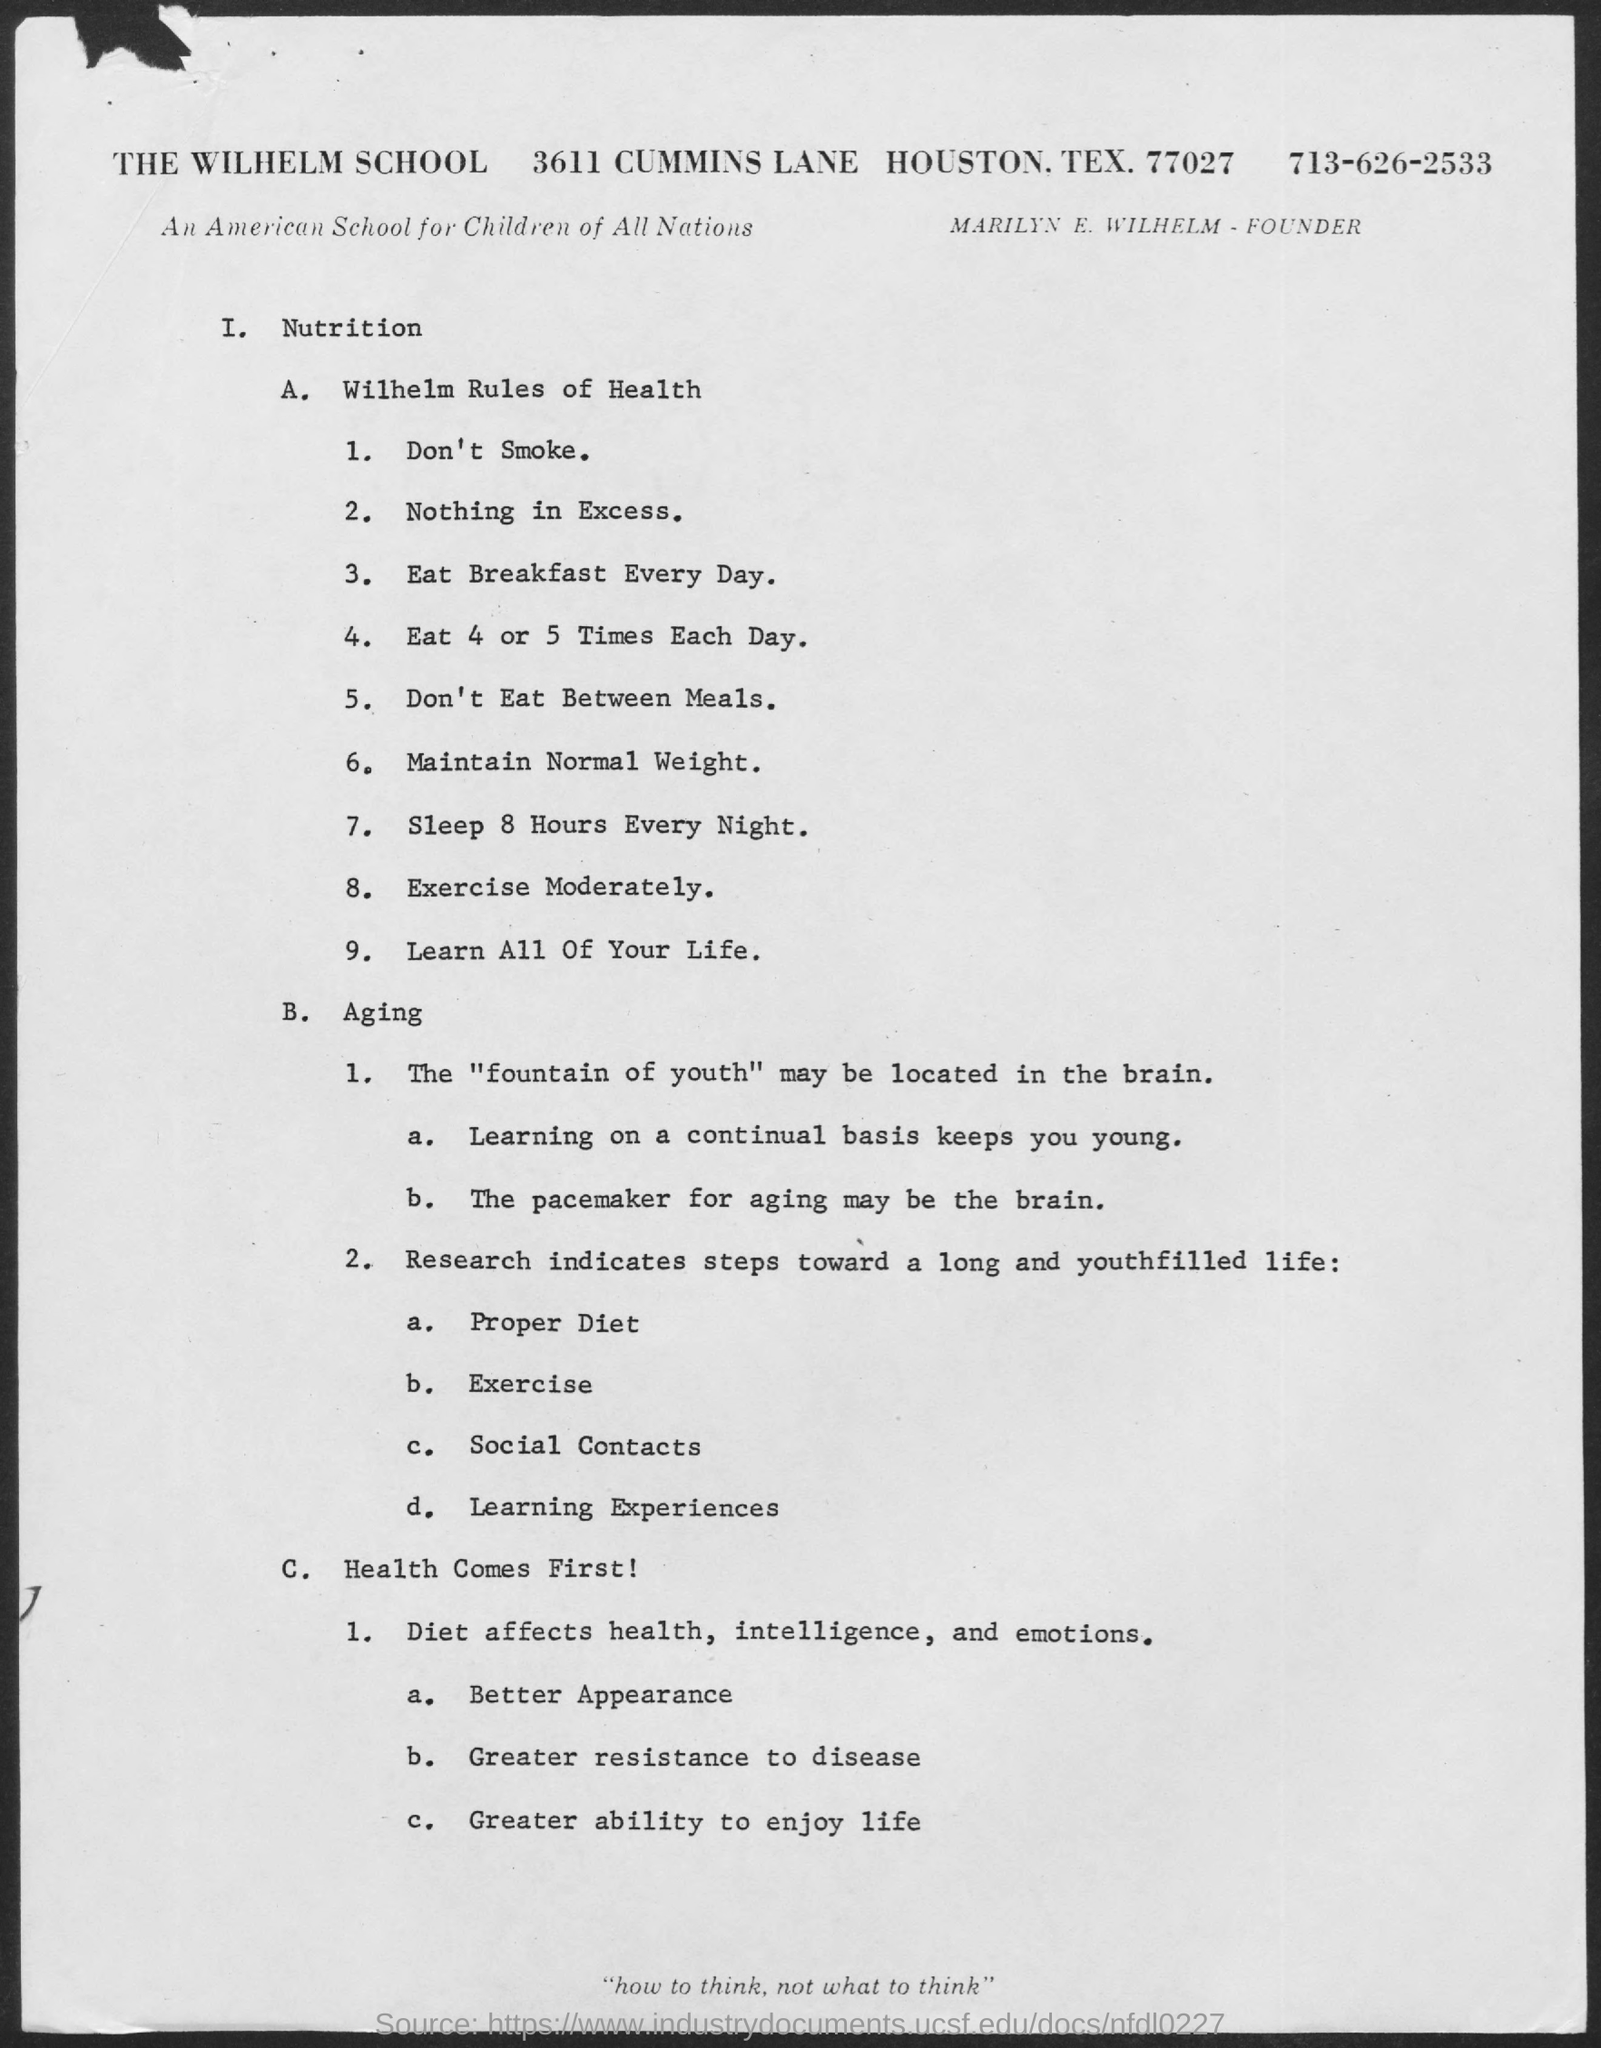Who is the Founder?
Your response must be concise. Marilyn E. Wilhelm. What is the name of the school?
Offer a terse response. THE WILHELM SCHOOL. What is the phone number mentioned in the document?
Provide a short and direct response. 713-626-2533. 